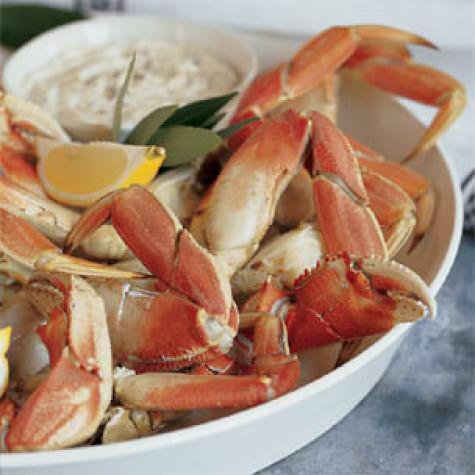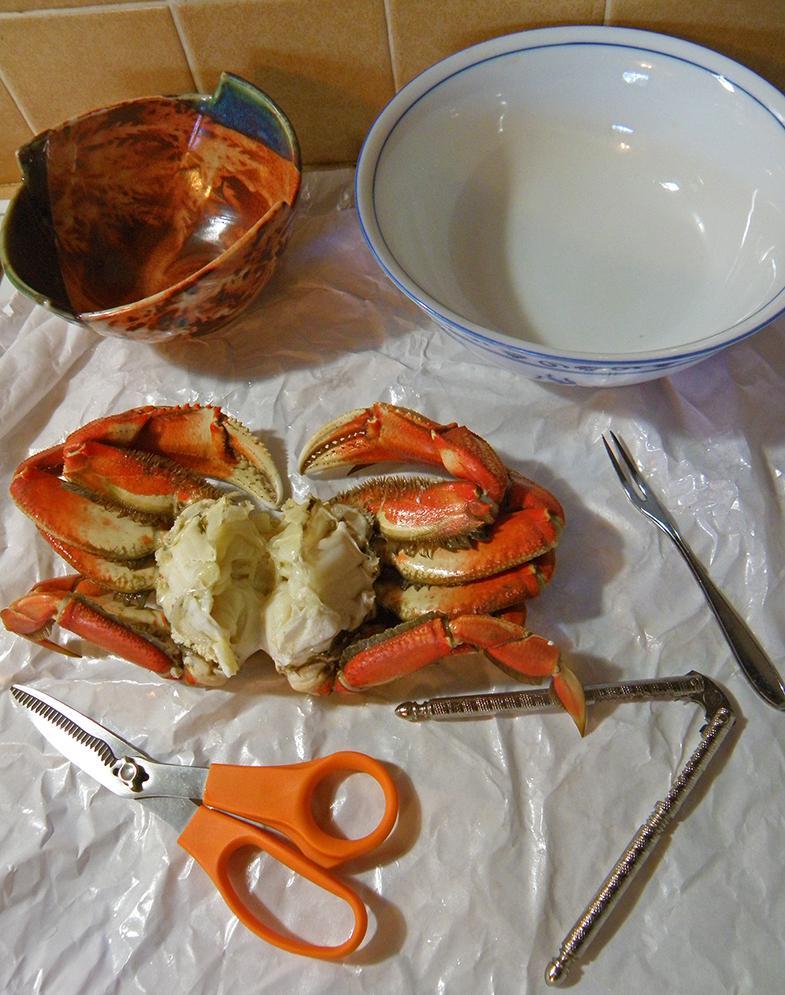The first image is the image on the left, the second image is the image on the right. Considering the images on both sides, is "In at least one image there is a single cooked crab upside down exposing it's soft parts." valid? Answer yes or no. Yes. The first image is the image on the left, the second image is the image on the right. For the images shown, is this caption "there is crab ready to serve with a wedge of lemon next to it" true? Answer yes or no. Yes. 